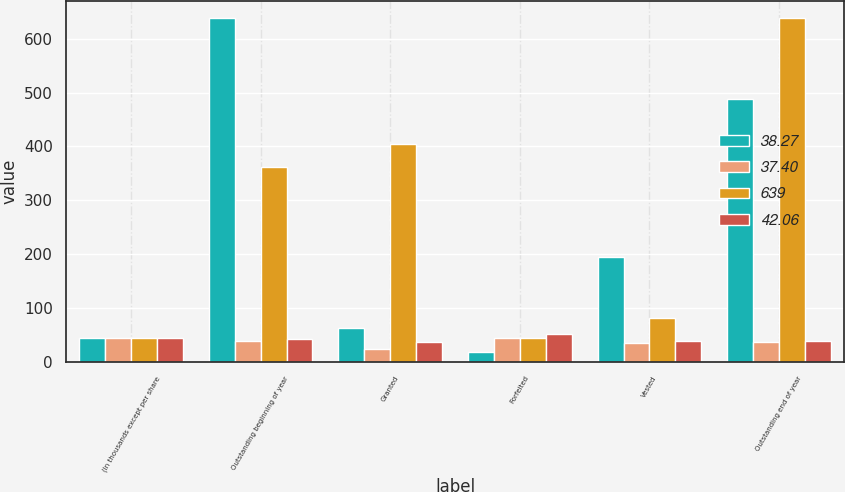<chart> <loc_0><loc_0><loc_500><loc_500><stacked_bar_chart><ecel><fcel>(In thousands except per share<fcel>Outstanding beginning of year<fcel>Granted<fcel>Forfeited<fcel>Vested<fcel>Outstanding end of year<nl><fcel>38.27<fcel>44.98<fcel>639<fcel>63<fcel>19<fcel>195<fcel>488<nl><fcel>37.4<fcel>44.98<fcel>38.27<fcel>24.36<fcel>44.96<fcel>35.32<fcel>37.4<nl><fcel>639<fcel>44.98<fcel>362<fcel>404<fcel>45<fcel>82<fcel>639<nl><fcel>42.06<fcel>44.98<fcel>42.06<fcel>36.55<fcel>51.74<fcel>39.63<fcel>38.27<nl></chart> 